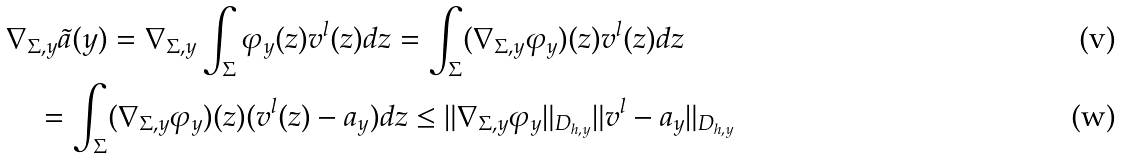<formula> <loc_0><loc_0><loc_500><loc_500>& \nabla _ { \Sigma , y } \tilde { a } ( y ) = \nabla _ { \Sigma , y } \int _ { \Sigma } \varphi _ { y } ( z ) v ^ { l } ( z ) d z = \int _ { \Sigma } ( \nabla _ { \Sigma , y } \varphi _ { y } ) ( z ) v ^ { l } ( z ) d z \\ & \quad = \int _ { \Sigma } ( \nabla _ { \Sigma , y } \varphi _ { y } ) ( z ) ( v ^ { l } ( z ) - a _ { y } ) d z \leq \| \nabla _ { \Sigma , { y } } \varphi _ { y } \| _ { D _ { h , y } } \| v ^ { l } - a _ { y } \| _ { D _ { h , y } }</formula> 